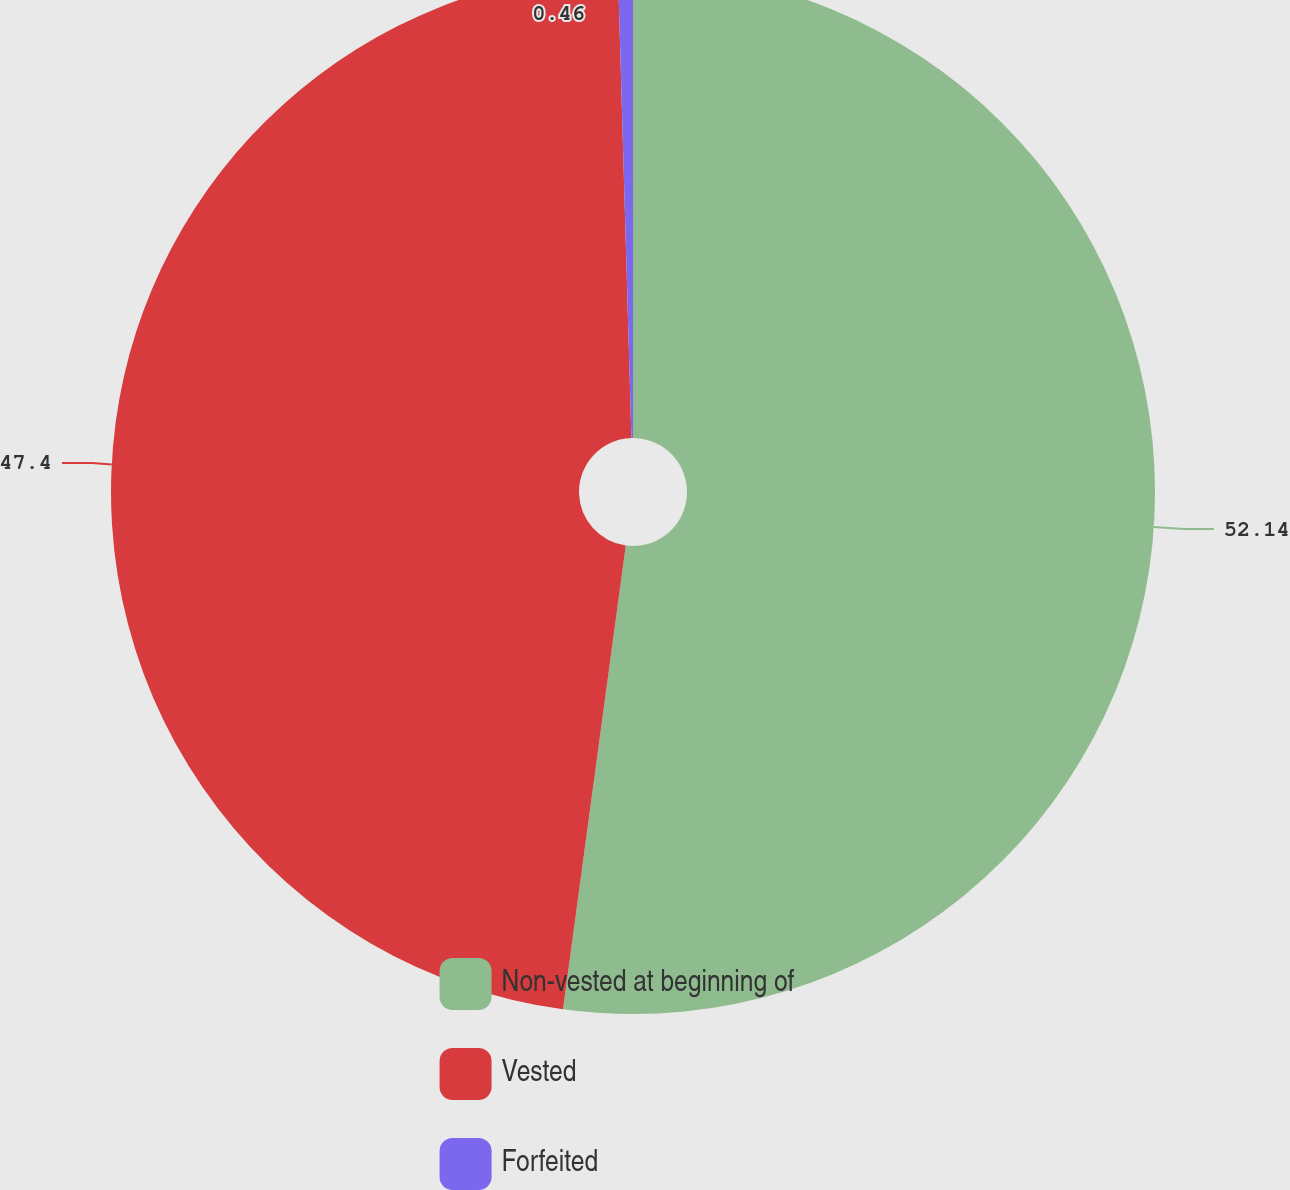Convert chart. <chart><loc_0><loc_0><loc_500><loc_500><pie_chart><fcel>Non-vested at beginning of<fcel>Vested<fcel>Forfeited<nl><fcel>52.14%<fcel>47.4%<fcel>0.46%<nl></chart> 